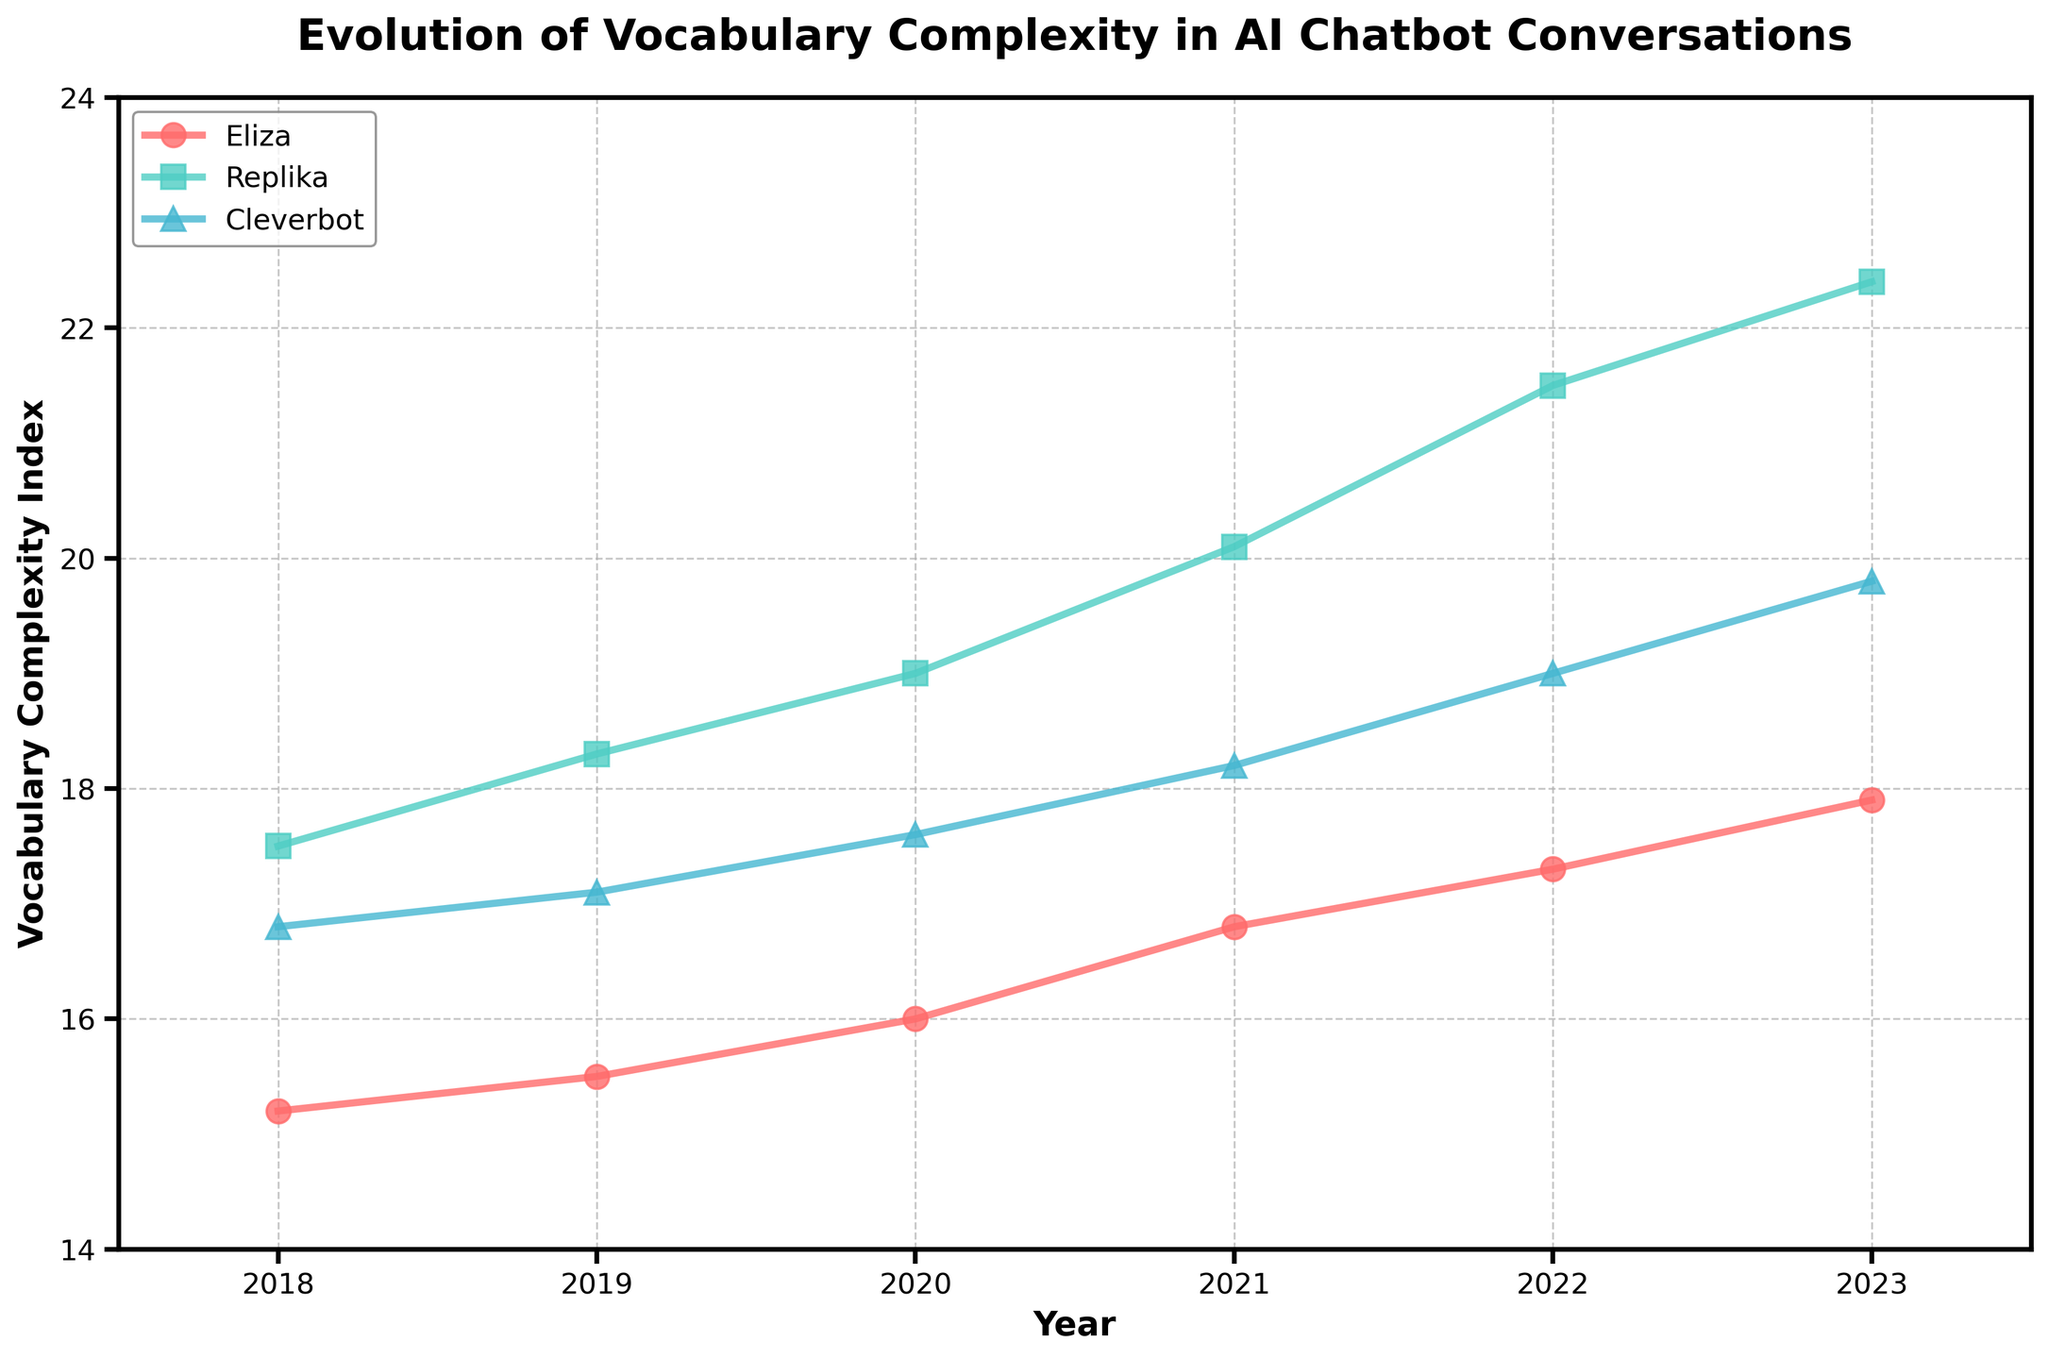What is the title of the figure? The title of the figure is usually displayed at the top and provides a quick understanding of what the plot is about.
Answer: Evolution of Vocabulary Complexity in AI Chatbot Conversations What is the vocabulary complexity index for Cleverbot in 2021? Find the year 2021 on the x-axis, then locate the point for Cleverbot by its corresponding color and marker (^). Read the y-axis value of that point.
Answer: 18.2 How has Replika's vocabulary complexity index changed from 2018 to 2023? Identify the points for Replika in the years 2018 and 2023 on the x-axis, then read their respective y-axis values. Subtract the value for 2018 from that of 2023.
Answer: Increased by 4.9 Which chatbot had the highest vocabulary complexity index in 2020? Look at the points corresponding to the year 2020 on the x-axis, compare the y-axis values for all three chatbots, and identify the chatbot with the highest value.
Answer: Replika What is the average vocabulary complexity index of Eliza over the years? Locate all points for Eliza across the years, sum their y-axis values, and divide by the number of years (6: from 2018 to 2023). Detailed steps: (15.2 + 15.5 + 16 + 16.8 + 17.3 + 17.9) / 6.
Answer: 16.45 Between 2018 and 2023, which chatbot shows the greatest overall improvement in vocabulary complexity index? Calculate the difference between the 2023 and 2018 y-axis values for each chatbot. Compare these differences to identify the chatbot with the greatest positive change.
Answer: Replika In which year did Eliza's vocabulary complexity index first exceed 16? Follow the timeline for Eliza's vocabulary complexity index and identify the first year where the y-axis value is greater than 16.
Answer: 2021 What is the trend in Cleverbot's vocabulary complexity from 2018 to 2023? Observe the y-axis values for Cleverbot from 2018 to 2023 and note the overall direction of change across the years.
Answer: Increasing Which year shows the most significant jump in Replika's vocabulary complexity index? Compare the annual differences in the vocabulary complexity index for Replika across consecutive years and identify the year with the largest increment.
Answer: 2021 to 2022 (1.4) 